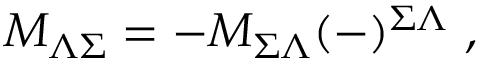<formula> <loc_0><loc_0><loc_500><loc_500>M _ { \Lambda \Sigma } = - M _ { \Sigma \Lambda } ( - ) ^ { \Sigma \Lambda } \ ,</formula> 